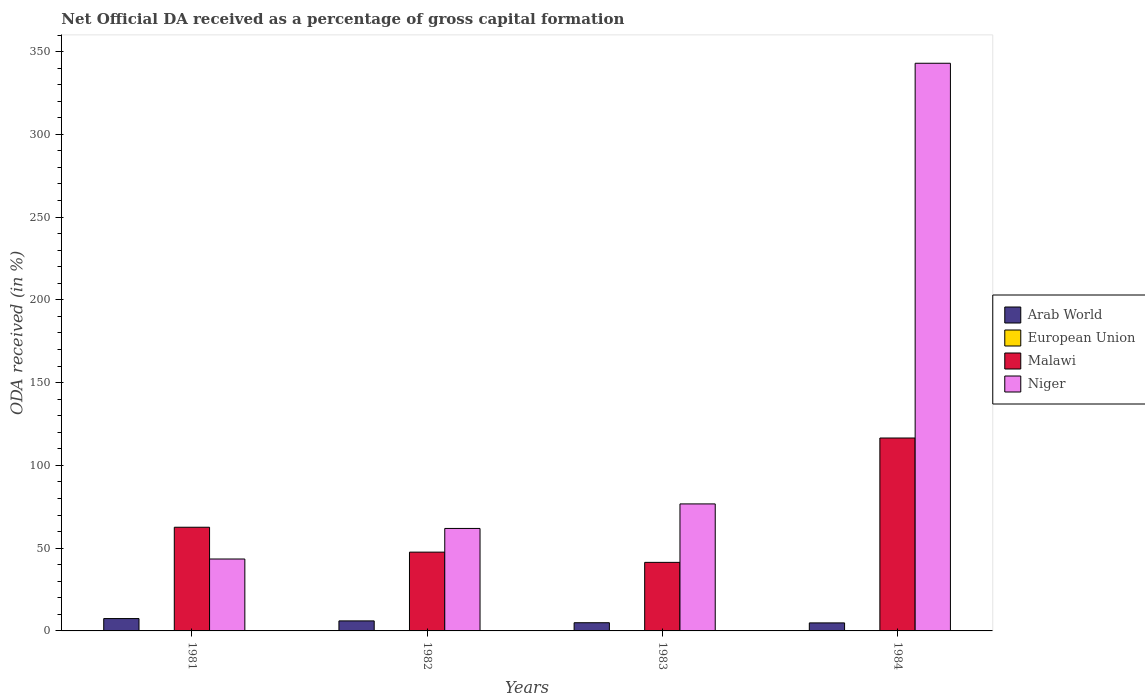How many different coloured bars are there?
Your answer should be compact. 4. How many groups of bars are there?
Your answer should be very brief. 4. Are the number of bars per tick equal to the number of legend labels?
Give a very brief answer. Yes. Are the number of bars on each tick of the X-axis equal?
Keep it short and to the point. Yes. How many bars are there on the 2nd tick from the right?
Your response must be concise. 4. What is the net ODA received in Niger in 1982?
Ensure brevity in your answer.  61.91. Across all years, what is the maximum net ODA received in Niger?
Your answer should be very brief. 342.93. Across all years, what is the minimum net ODA received in European Union?
Ensure brevity in your answer.  0. What is the total net ODA received in Niger in the graph?
Make the answer very short. 525.01. What is the difference between the net ODA received in European Union in 1983 and that in 1984?
Ensure brevity in your answer.  0. What is the difference between the net ODA received in Arab World in 1981 and the net ODA received in Niger in 1984?
Provide a succinct answer. -335.47. What is the average net ODA received in Niger per year?
Your answer should be compact. 131.25. In the year 1981, what is the difference between the net ODA received in European Union and net ODA received in Niger?
Your answer should be very brief. -43.43. What is the ratio of the net ODA received in Malawi in 1982 to that in 1984?
Ensure brevity in your answer.  0.41. Is the difference between the net ODA received in European Union in 1981 and 1984 greater than the difference between the net ODA received in Niger in 1981 and 1984?
Offer a terse response. Yes. What is the difference between the highest and the second highest net ODA received in Niger?
Give a very brief answer. 266.2. What is the difference between the highest and the lowest net ODA received in Malawi?
Provide a short and direct response. 75.13. Is it the case that in every year, the sum of the net ODA received in Malawi and net ODA received in European Union is greater than the sum of net ODA received in Arab World and net ODA received in Niger?
Your answer should be compact. No. What does the 4th bar from the left in 1984 represents?
Give a very brief answer. Niger. What does the 4th bar from the right in 1983 represents?
Make the answer very short. Arab World. Is it the case that in every year, the sum of the net ODA received in Arab World and net ODA received in Niger is greater than the net ODA received in Malawi?
Make the answer very short. No. Are all the bars in the graph horizontal?
Make the answer very short. No. What is the difference between two consecutive major ticks on the Y-axis?
Provide a succinct answer. 50. Are the values on the major ticks of Y-axis written in scientific E-notation?
Make the answer very short. No. Does the graph contain grids?
Provide a short and direct response. No. How are the legend labels stacked?
Offer a very short reply. Vertical. What is the title of the graph?
Your response must be concise. Net Official DA received as a percentage of gross capital formation. What is the label or title of the X-axis?
Provide a short and direct response. Years. What is the label or title of the Y-axis?
Offer a terse response. ODA received (in %). What is the ODA received (in %) in Arab World in 1981?
Offer a terse response. 7.47. What is the ODA received (in %) in European Union in 1981?
Your answer should be compact. 0.01. What is the ODA received (in %) of Malawi in 1981?
Ensure brevity in your answer.  62.64. What is the ODA received (in %) of Niger in 1981?
Your answer should be very brief. 43.44. What is the ODA received (in %) in Arab World in 1982?
Ensure brevity in your answer.  6.05. What is the ODA received (in %) in European Union in 1982?
Your answer should be compact. 0.01. What is the ODA received (in %) of Malawi in 1982?
Your answer should be compact. 47.6. What is the ODA received (in %) of Niger in 1982?
Your response must be concise. 61.91. What is the ODA received (in %) in Arab World in 1983?
Keep it short and to the point. 4.95. What is the ODA received (in %) in European Union in 1983?
Give a very brief answer. 0.01. What is the ODA received (in %) of Malawi in 1983?
Your response must be concise. 41.41. What is the ODA received (in %) of Niger in 1983?
Ensure brevity in your answer.  76.73. What is the ODA received (in %) in Arab World in 1984?
Offer a terse response. 4.85. What is the ODA received (in %) in European Union in 1984?
Offer a very short reply. 0. What is the ODA received (in %) in Malawi in 1984?
Give a very brief answer. 116.54. What is the ODA received (in %) of Niger in 1984?
Your answer should be compact. 342.93. Across all years, what is the maximum ODA received (in %) in Arab World?
Keep it short and to the point. 7.47. Across all years, what is the maximum ODA received (in %) of European Union?
Your response must be concise. 0.01. Across all years, what is the maximum ODA received (in %) of Malawi?
Provide a short and direct response. 116.54. Across all years, what is the maximum ODA received (in %) in Niger?
Provide a succinct answer. 342.93. Across all years, what is the minimum ODA received (in %) of Arab World?
Ensure brevity in your answer.  4.85. Across all years, what is the minimum ODA received (in %) of European Union?
Keep it short and to the point. 0. Across all years, what is the minimum ODA received (in %) in Malawi?
Give a very brief answer. 41.41. Across all years, what is the minimum ODA received (in %) of Niger?
Give a very brief answer. 43.44. What is the total ODA received (in %) of Arab World in the graph?
Make the answer very short. 23.32. What is the total ODA received (in %) in European Union in the graph?
Your answer should be very brief. 0.03. What is the total ODA received (in %) in Malawi in the graph?
Make the answer very short. 268.2. What is the total ODA received (in %) in Niger in the graph?
Your answer should be very brief. 525.01. What is the difference between the ODA received (in %) in Arab World in 1981 and that in 1982?
Provide a succinct answer. 1.41. What is the difference between the ODA received (in %) of European Union in 1981 and that in 1982?
Your answer should be very brief. 0. What is the difference between the ODA received (in %) of Malawi in 1981 and that in 1982?
Your answer should be very brief. 15.04. What is the difference between the ODA received (in %) in Niger in 1981 and that in 1982?
Provide a short and direct response. -18.47. What is the difference between the ODA received (in %) in Arab World in 1981 and that in 1983?
Make the answer very short. 2.51. What is the difference between the ODA received (in %) in European Union in 1981 and that in 1983?
Ensure brevity in your answer.  0. What is the difference between the ODA received (in %) in Malawi in 1981 and that in 1983?
Give a very brief answer. 21.22. What is the difference between the ODA received (in %) of Niger in 1981 and that in 1983?
Ensure brevity in your answer.  -33.29. What is the difference between the ODA received (in %) of Arab World in 1981 and that in 1984?
Your answer should be compact. 2.62. What is the difference between the ODA received (in %) of European Union in 1981 and that in 1984?
Your answer should be compact. 0.01. What is the difference between the ODA received (in %) of Malawi in 1981 and that in 1984?
Provide a short and direct response. -53.9. What is the difference between the ODA received (in %) in Niger in 1981 and that in 1984?
Your response must be concise. -299.49. What is the difference between the ODA received (in %) of Arab World in 1982 and that in 1983?
Give a very brief answer. 1.1. What is the difference between the ODA received (in %) of European Union in 1982 and that in 1983?
Provide a short and direct response. -0. What is the difference between the ODA received (in %) of Malawi in 1982 and that in 1983?
Provide a succinct answer. 6.19. What is the difference between the ODA received (in %) of Niger in 1982 and that in 1983?
Offer a terse response. -14.82. What is the difference between the ODA received (in %) of Arab World in 1982 and that in 1984?
Provide a short and direct response. 1.21. What is the difference between the ODA received (in %) of European Union in 1982 and that in 1984?
Provide a succinct answer. 0. What is the difference between the ODA received (in %) of Malawi in 1982 and that in 1984?
Your answer should be very brief. -68.94. What is the difference between the ODA received (in %) in Niger in 1982 and that in 1984?
Provide a succinct answer. -281.03. What is the difference between the ODA received (in %) in Arab World in 1983 and that in 1984?
Provide a short and direct response. 0.1. What is the difference between the ODA received (in %) in European Union in 1983 and that in 1984?
Provide a succinct answer. 0. What is the difference between the ODA received (in %) of Malawi in 1983 and that in 1984?
Provide a succinct answer. -75.13. What is the difference between the ODA received (in %) of Niger in 1983 and that in 1984?
Provide a succinct answer. -266.2. What is the difference between the ODA received (in %) in Arab World in 1981 and the ODA received (in %) in European Union in 1982?
Make the answer very short. 7.46. What is the difference between the ODA received (in %) of Arab World in 1981 and the ODA received (in %) of Malawi in 1982?
Offer a terse response. -40.14. What is the difference between the ODA received (in %) in Arab World in 1981 and the ODA received (in %) in Niger in 1982?
Ensure brevity in your answer.  -54.44. What is the difference between the ODA received (in %) in European Union in 1981 and the ODA received (in %) in Malawi in 1982?
Make the answer very short. -47.59. What is the difference between the ODA received (in %) in European Union in 1981 and the ODA received (in %) in Niger in 1982?
Provide a succinct answer. -61.9. What is the difference between the ODA received (in %) in Malawi in 1981 and the ODA received (in %) in Niger in 1982?
Provide a succinct answer. 0.73. What is the difference between the ODA received (in %) in Arab World in 1981 and the ODA received (in %) in European Union in 1983?
Make the answer very short. 7.46. What is the difference between the ODA received (in %) in Arab World in 1981 and the ODA received (in %) in Malawi in 1983?
Your response must be concise. -33.95. What is the difference between the ODA received (in %) of Arab World in 1981 and the ODA received (in %) of Niger in 1983?
Your answer should be very brief. -69.26. What is the difference between the ODA received (in %) in European Union in 1981 and the ODA received (in %) in Malawi in 1983?
Your answer should be compact. -41.4. What is the difference between the ODA received (in %) in European Union in 1981 and the ODA received (in %) in Niger in 1983?
Your response must be concise. -76.72. What is the difference between the ODA received (in %) in Malawi in 1981 and the ODA received (in %) in Niger in 1983?
Your answer should be very brief. -14.09. What is the difference between the ODA received (in %) of Arab World in 1981 and the ODA received (in %) of European Union in 1984?
Provide a succinct answer. 7.46. What is the difference between the ODA received (in %) in Arab World in 1981 and the ODA received (in %) in Malawi in 1984?
Offer a very short reply. -109.08. What is the difference between the ODA received (in %) in Arab World in 1981 and the ODA received (in %) in Niger in 1984?
Make the answer very short. -335.47. What is the difference between the ODA received (in %) of European Union in 1981 and the ODA received (in %) of Malawi in 1984?
Provide a succinct answer. -116.53. What is the difference between the ODA received (in %) of European Union in 1981 and the ODA received (in %) of Niger in 1984?
Make the answer very short. -342.92. What is the difference between the ODA received (in %) of Malawi in 1981 and the ODA received (in %) of Niger in 1984?
Your answer should be compact. -280.3. What is the difference between the ODA received (in %) in Arab World in 1982 and the ODA received (in %) in European Union in 1983?
Your response must be concise. 6.04. What is the difference between the ODA received (in %) of Arab World in 1982 and the ODA received (in %) of Malawi in 1983?
Offer a very short reply. -35.36. What is the difference between the ODA received (in %) of Arab World in 1982 and the ODA received (in %) of Niger in 1983?
Make the answer very short. -70.68. What is the difference between the ODA received (in %) in European Union in 1982 and the ODA received (in %) in Malawi in 1983?
Offer a very short reply. -41.41. What is the difference between the ODA received (in %) of European Union in 1982 and the ODA received (in %) of Niger in 1983?
Make the answer very short. -76.72. What is the difference between the ODA received (in %) in Malawi in 1982 and the ODA received (in %) in Niger in 1983?
Offer a terse response. -29.13. What is the difference between the ODA received (in %) of Arab World in 1982 and the ODA received (in %) of European Union in 1984?
Offer a terse response. 6.05. What is the difference between the ODA received (in %) of Arab World in 1982 and the ODA received (in %) of Malawi in 1984?
Make the answer very short. -110.49. What is the difference between the ODA received (in %) in Arab World in 1982 and the ODA received (in %) in Niger in 1984?
Provide a short and direct response. -336.88. What is the difference between the ODA received (in %) in European Union in 1982 and the ODA received (in %) in Malawi in 1984?
Your answer should be compact. -116.53. What is the difference between the ODA received (in %) in European Union in 1982 and the ODA received (in %) in Niger in 1984?
Provide a short and direct response. -342.93. What is the difference between the ODA received (in %) of Malawi in 1982 and the ODA received (in %) of Niger in 1984?
Provide a succinct answer. -295.33. What is the difference between the ODA received (in %) in Arab World in 1983 and the ODA received (in %) in European Union in 1984?
Provide a short and direct response. 4.95. What is the difference between the ODA received (in %) in Arab World in 1983 and the ODA received (in %) in Malawi in 1984?
Your answer should be very brief. -111.59. What is the difference between the ODA received (in %) in Arab World in 1983 and the ODA received (in %) in Niger in 1984?
Offer a terse response. -337.98. What is the difference between the ODA received (in %) of European Union in 1983 and the ODA received (in %) of Malawi in 1984?
Make the answer very short. -116.53. What is the difference between the ODA received (in %) of European Union in 1983 and the ODA received (in %) of Niger in 1984?
Your answer should be compact. -342.93. What is the difference between the ODA received (in %) of Malawi in 1983 and the ODA received (in %) of Niger in 1984?
Keep it short and to the point. -301.52. What is the average ODA received (in %) in Arab World per year?
Offer a terse response. 5.83. What is the average ODA received (in %) of European Union per year?
Your response must be concise. 0.01. What is the average ODA received (in %) of Malawi per year?
Your answer should be very brief. 67.05. What is the average ODA received (in %) of Niger per year?
Your answer should be very brief. 131.25. In the year 1981, what is the difference between the ODA received (in %) in Arab World and ODA received (in %) in European Union?
Keep it short and to the point. 7.45. In the year 1981, what is the difference between the ODA received (in %) of Arab World and ODA received (in %) of Malawi?
Offer a terse response. -55.17. In the year 1981, what is the difference between the ODA received (in %) of Arab World and ODA received (in %) of Niger?
Give a very brief answer. -35.97. In the year 1981, what is the difference between the ODA received (in %) of European Union and ODA received (in %) of Malawi?
Offer a terse response. -62.63. In the year 1981, what is the difference between the ODA received (in %) of European Union and ODA received (in %) of Niger?
Your answer should be compact. -43.43. In the year 1981, what is the difference between the ODA received (in %) of Malawi and ODA received (in %) of Niger?
Provide a short and direct response. 19.2. In the year 1982, what is the difference between the ODA received (in %) in Arab World and ODA received (in %) in European Union?
Your answer should be compact. 6.05. In the year 1982, what is the difference between the ODA received (in %) of Arab World and ODA received (in %) of Malawi?
Give a very brief answer. -41.55. In the year 1982, what is the difference between the ODA received (in %) in Arab World and ODA received (in %) in Niger?
Make the answer very short. -55.85. In the year 1982, what is the difference between the ODA received (in %) of European Union and ODA received (in %) of Malawi?
Your response must be concise. -47.59. In the year 1982, what is the difference between the ODA received (in %) in European Union and ODA received (in %) in Niger?
Your answer should be very brief. -61.9. In the year 1982, what is the difference between the ODA received (in %) of Malawi and ODA received (in %) of Niger?
Keep it short and to the point. -14.31. In the year 1983, what is the difference between the ODA received (in %) of Arab World and ODA received (in %) of European Union?
Make the answer very short. 4.94. In the year 1983, what is the difference between the ODA received (in %) in Arab World and ODA received (in %) in Malawi?
Offer a very short reply. -36.46. In the year 1983, what is the difference between the ODA received (in %) of Arab World and ODA received (in %) of Niger?
Ensure brevity in your answer.  -71.78. In the year 1983, what is the difference between the ODA received (in %) of European Union and ODA received (in %) of Malawi?
Give a very brief answer. -41.41. In the year 1983, what is the difference between the ODA received (in %) of European Union and ODA received (in %) of Niger?
Your answer should be very brief. -76.72. In the year 1983, what is the difference between the ODA received (in %) in Malawi and ODA received (in %) in Niger?
Offer a terse response. -35.32. In the year 1984, what is the difference between the ODA received (in %) in Arab World and ODA received (in %) in European Union?
Your answer should be very brief. 4.84. In the year 1984, what is the difference between the ODA received (in %) of Arab World and ODA received (in %) of Malawi?
Provide a short and direct response. -111.69. In the year 1984, what is the difference between the ODA received (in %) in Arab World and ODA received (in %) in Niger?
Offer a very short reply. -338.09. In the year 1984, what is the difference between the ODA received (in %) of European Union and ODA received (in %) of Malawi?
Offer a terse response. -116.54. In the year 1984, what is the difference between the ODA received (in %) in European Union and ODA received (in %) in Niger?
Your response must be concise. -342.93. In the year 1984, what is the difference between the ODA received (in %) in Malawi and ODA received (in %) in Niger?
Offer a very short reply. -226.39. What is the ratio of the ODA received (in %) of Arab World in 1981 to that in 1982?
Offer a very short reply. 1.23. What is the ratio of the ODA received (in %) of European Union in 1981 to that in 1982?
Offer a very short reply. 1.58. What is the ratio of the ODA received (in %) of Malawi in 1981 to that in 1982?
Make the answer very short. 1.32. What is the ratio of the ODA received (in %) in Niger in 1981 to that in 1982?
Offer a terse response. 0.7. What is the ratio of the ODA received (in %) of Arab World in 1981 to that in 1983?
Provide a succinct answer. 1.51. What is the ratio of the ODA received (in %) of European Union in 1981 to that in 1983?
Your response must be concise. 1.34. What is the ratio of the ODA received (in %) of Malawi in 1981 to that in 1983?
Give a very brief answer. 1.51. What is the ratio of the ODA received (in %) in Niger in 1981 to that in 1983?
Your answer should be compact. 0.57. What is the ratio of the ODA received (in %) of Arab World in 1981 to that in 1984?
Provide a short and direct response. 1.54. What is the ratio of the ODA received (in %) of European Union in 1981 to that in 1984?
Your response must be concise. 2.88. What is the ratio of the ODA received (in %) in Malawi in 1981 to that in 1984?
Offer a terse response. 0.54. What is the ratio of the ODA received (in %) in Niger in 1981 to that in 1984?
Keep it short and to the point. 0.13. What is the ratio of the ODA received (in %) of Arab World in 1982 to that in 1983?
Offer a terse response. 1.22. What is the ratio of the ODA received (in %) in European Union in 1982 to that in 1983?
Offer a terse response. 0.85. What is the ratio of the ODA received (in %) of Malawi in 1982 to that in 1983?
Your answer should be very brief. 1.15. What is the ratio of the ODA received (in %) of Niger in 1982 to that in 1983?
Make the answer very short. 0.81. What is the ratio of the ODA received (in %) in Arab World in 1982 to that in 1984?
Provide a short and direct response. 1.25. What is the ratio of the ODA received (in %) of European Union in 1982 to that in 1984?
Keep it short and to the point. 1.82. What is the ratio of the ODA received (in %) in Malawi in 1982 to that in 1984?
Give a very brief answer. 0.41. What is the ratio of the ODA received (in %) in Niger in 1982 to that in 1984?
Your answer should be very brief. 0.18. What is the ratio of the ODA received (in %) of Arab World in 1983 to that in 1984?
Make the answer very short. 1.02. What is the ratio of the ODA received (in %) of European Union in 1983 to that in 1984?
Provide a succinct answer. 2.15. What is the ratio of the ODA received (in %) of Malawi in 1983 to that in 1984?
Offer a very short reply. 0.36. What is the ratio of the ODA received (in %) in Niger in 1983 to that in 1984?
Give a very brief answer. 0.22. What is the difference between the highest and the second highest ODA received (in %) of Arab World?
Offer a terse response. 1.41. What is the difference between the highest and the second highest ODA received (in %) of European Union?
Offer a very short reply. 0. What is the difference between the highest and the second highest ODA received (in %) in Malawi?
Provide a succinct answer. 53.9. What is the difference between the highest and the second highest ODA received (in %) in Niger?
Offer a very short reply. 266.2. What is the difference between the highest and the lowest ODA received (in %) of Arab World?
Your answer should be very brief. 2.62. What is the difference between the highest and the lowest ODA received (in %) in European Union?
Give a very brief answer. 0.01. What is the difference between the highest and the lowest ODA received (in %) of Malawi?
Ensure brevity in your answer.  75.13. What is the difference between the highest and the lowest ODA received (in %) in Niger?
Provide a short and direct response. 299.49. 